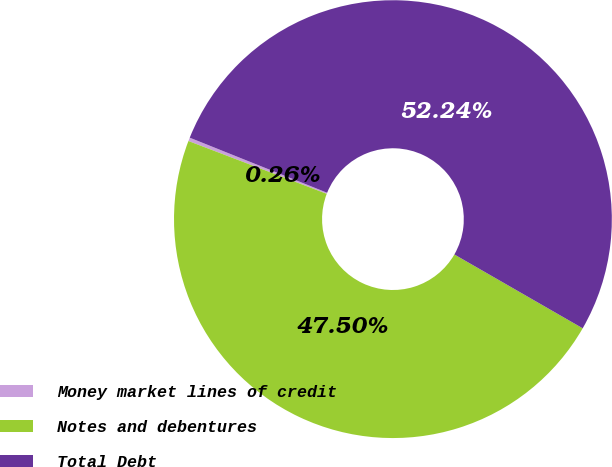<chart> <loc_0><loc_0><loc_500><loc_500><pie_chart><fcel>Money market lines of credit<fcel>Notes and debentures<fcel>Total Debt<nl><fcel>0.26%<fcel>47.5%<fcel>52.24%<nl></chart> 